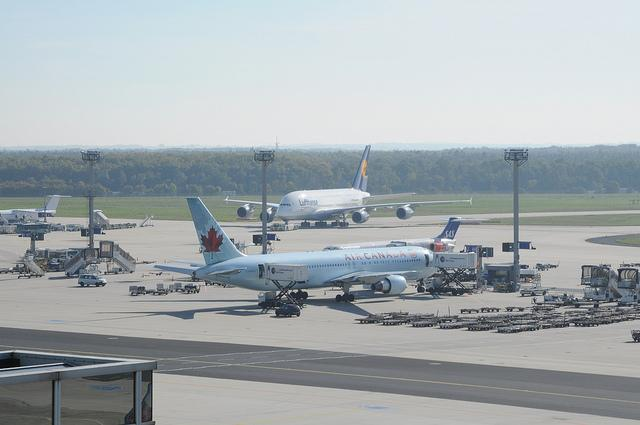What continent is the plane in the foreground from?

Choices:
A) antarctica
B) asia
C) north america
D) south america north america 